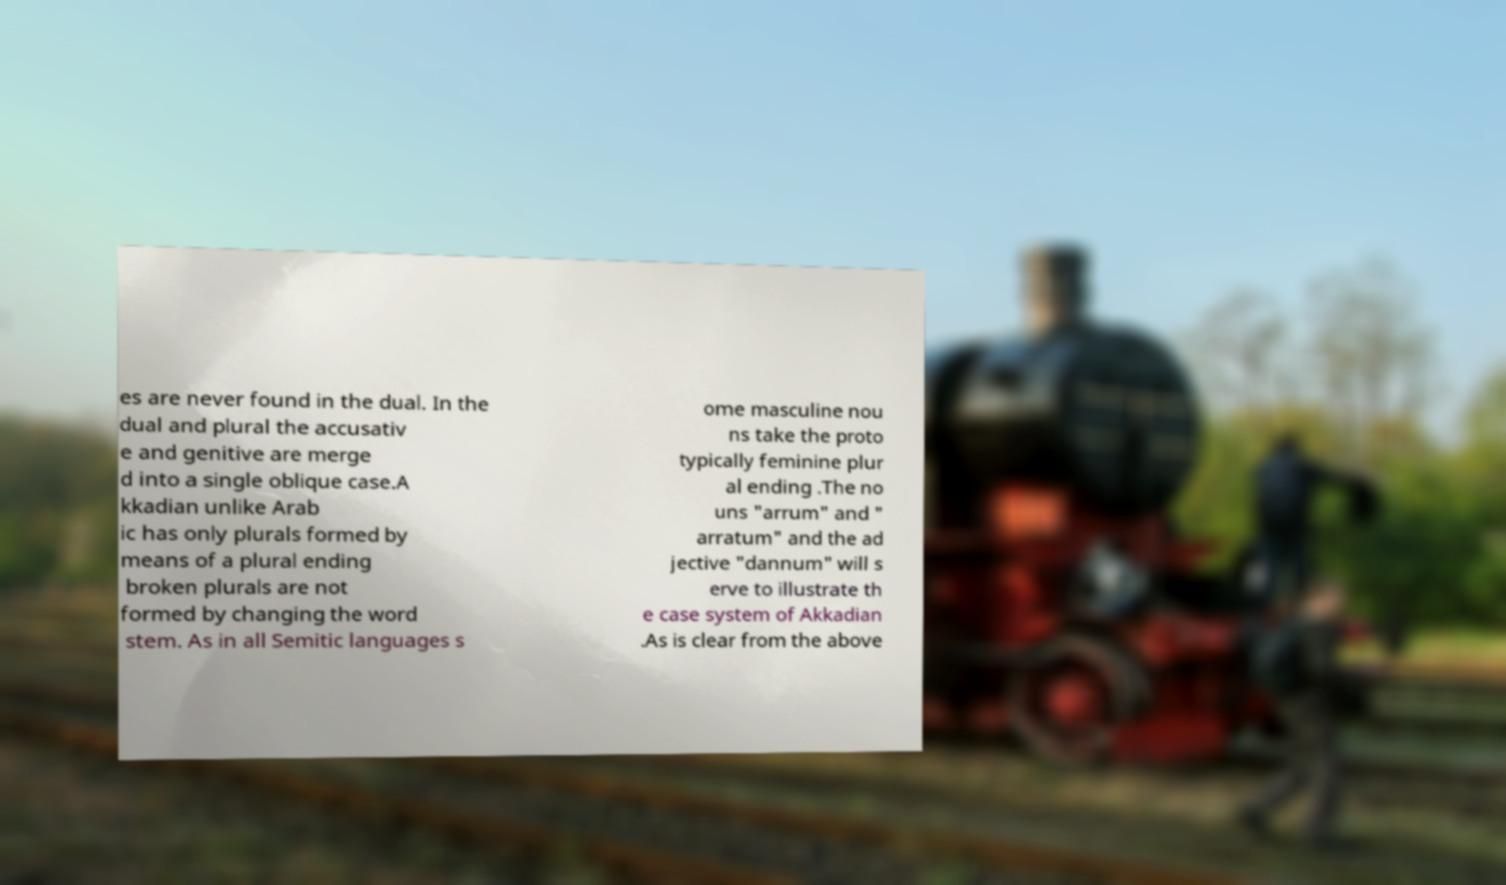Please read and relay the text visible in this image. What does it say? es are never found in the dual. In the dual and plural the accusativ e and genitive are merge d into a single oblique case.A kkadian unlike Arab ic has only plurals formed by means of a plural ending broken plurals are not formed by changing the word stem. As in all Semitic languages s ome masculine nou ns take the proto typically feminine plur al ending .The no uns "arrum" and " arratum" and the ad jective "dannum" will s erve to illustrate th e case system of Akkadian .As is clear from the above 